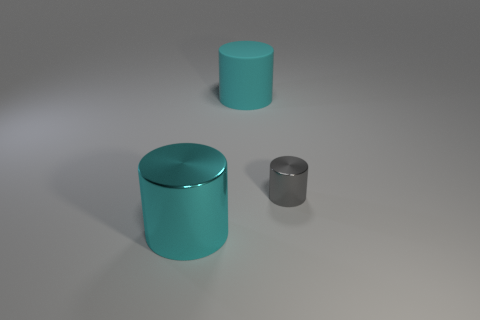Subtract all tiny cylinders. How many cylinders are left? 2 Subtract all gray cylinders. How many cylinders are left? 2 Add 3 small yellow metallic blocks. How many objects exist? 6 Subtract 3 cylinders. How many cylinders are left? 0 Subtract all big cyan metal cylinders. Subtract all matte cylinders. How many objects are left? 1 Add 1 big rubber cylinders. How many big rubber cylinders are left? 2 Add 3 red things. How many red things exist? 3 Subtract 0 yellow blocks. How many objects are left? 3 Subtract all cyan cylinders. Subtract all brown cubes. How many cylinders are left? 1 Subtract all blue balls. How many brown cylinders are left? 0 